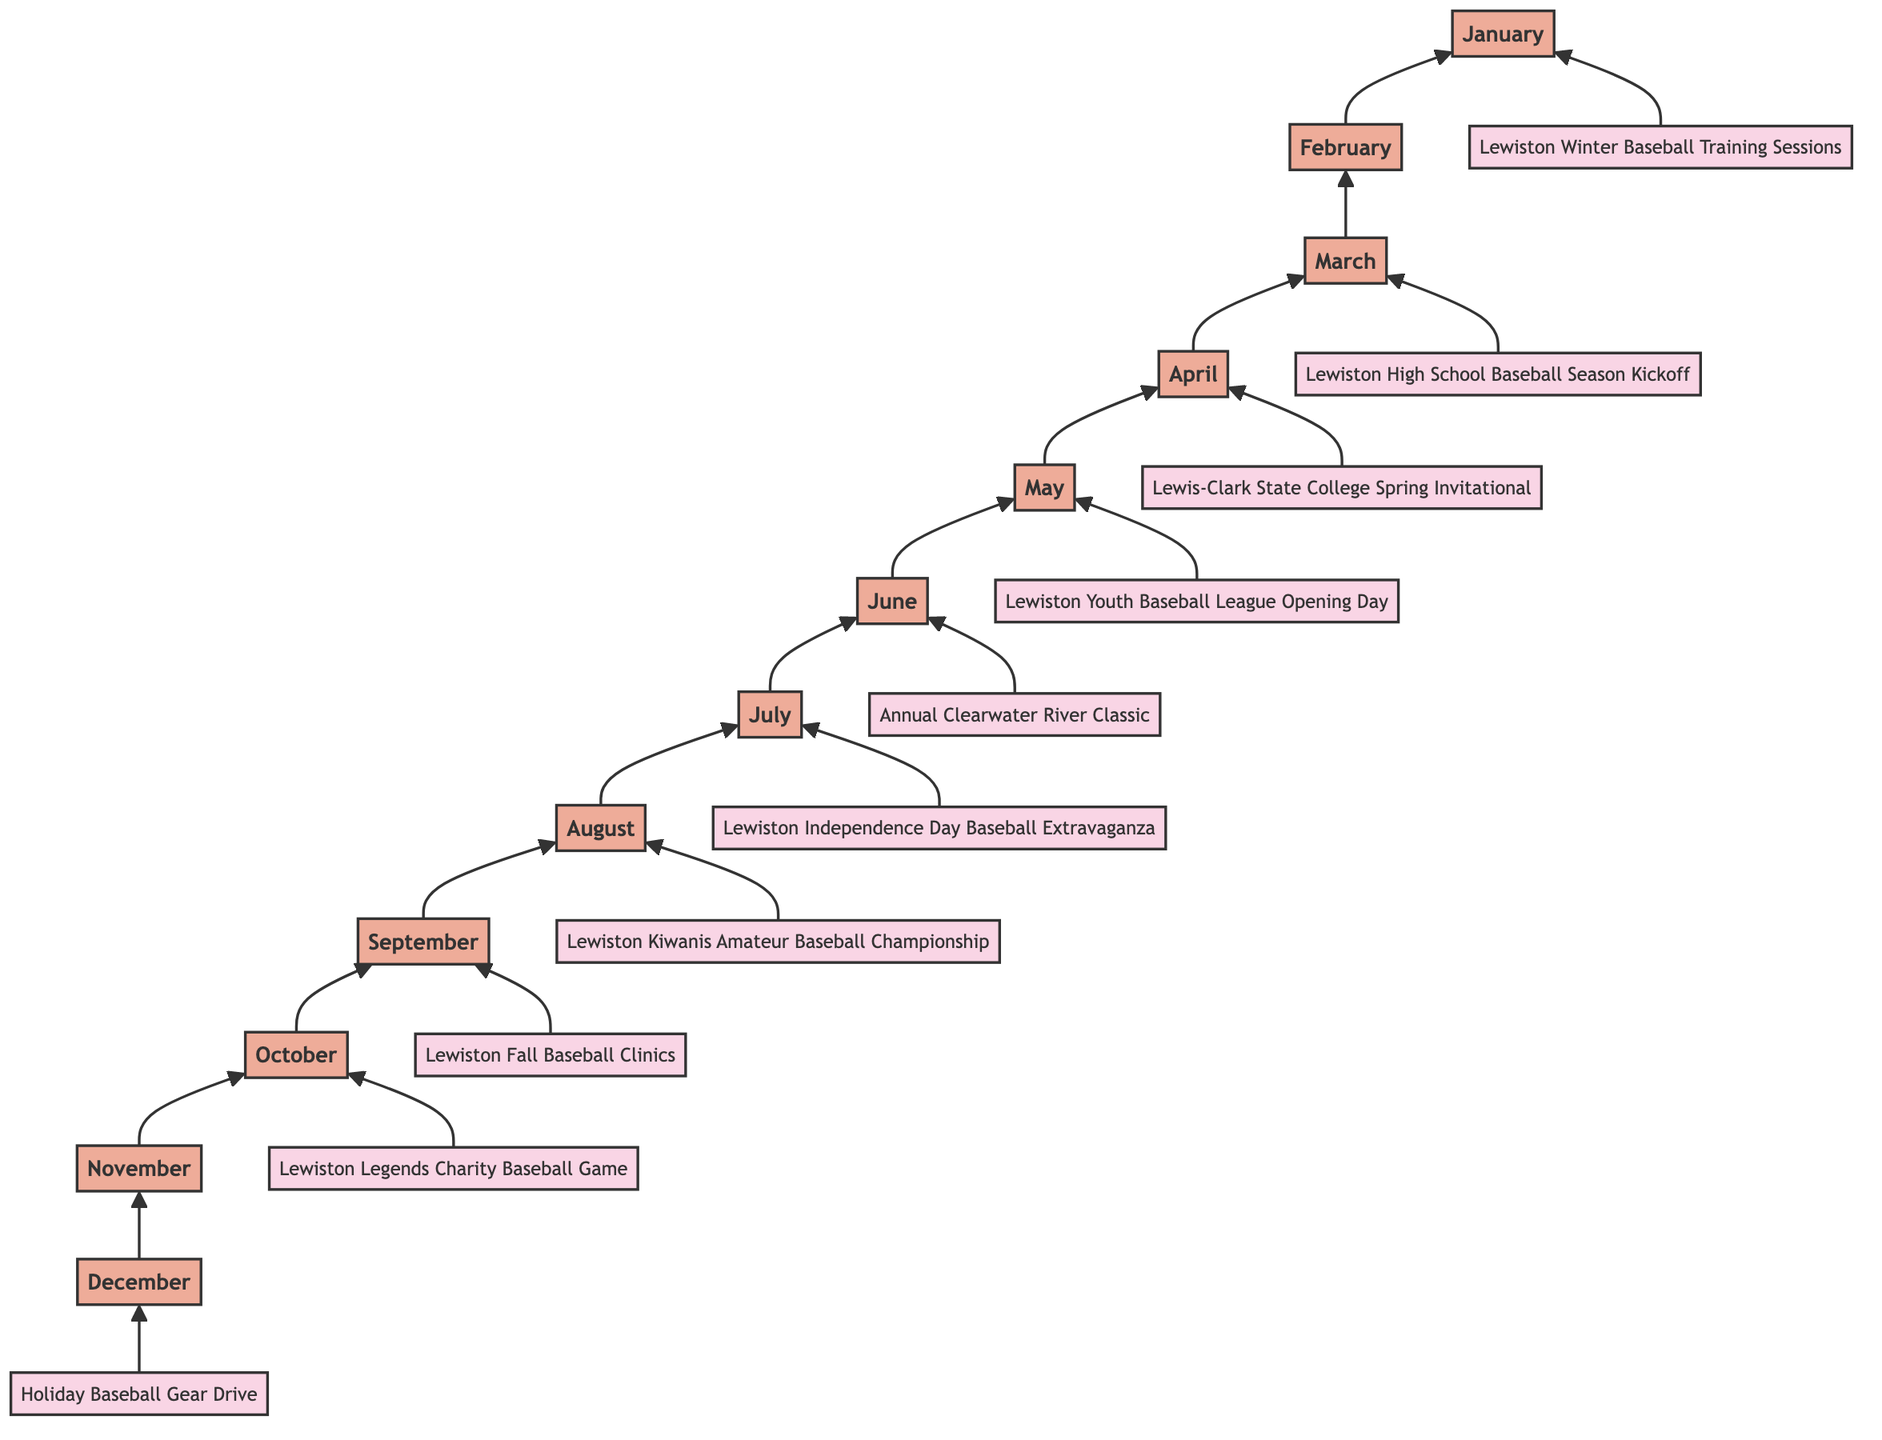What is the first event listed in the diagram? The first event is located at the bottom of the flow chart, which starts with the month of January. The event corresponding to January is "Lewiston Winter Baseball Training Sessions."
Answer: Lewiston Winter Baseball Training Sessions How many months are represented in the diagram? The diagram has a month node for each calendar month from December to January, making a total of 12 months included.
Answer: 12 Which month features the "Lewiston Youth Baseball League Opening Day"? By following the flow from the bottom to the top, I locate the event "Lewiston Youth Baseball League Opening Day," which is associated with the month of May.
Answer: May What event occurs right before the "Lewiston Legends Charity Baseball Game"? The event directly preceding the "Lewiston Legends Charity Baseball Game" is indicated in the diagram, which shows it occurs in October, while September holds the event "Lewiston Fall Baseball Clinics."
Answer: Lewiston Fall Baseball Clinics In which month do the Annual Clearwater River Classic take place? The diagram shows that this annual tournament is associated with the month of June, as this event points to June as outlined in the event nodes.
Answer: June Which event is scheduled for August? The diagram identifies the event scheduled for August as "Lewiston Kiwanis Amateur Baseball Championship."
Answer: Lewiston Kiwanis Amateur Baseball Championship How many events are listed in total in the diagram? Each event node corresponds to each month, and since there are 12 months, we conclude that there are also 12 events in total.
Answer: 12 Which month has the "Holiday Baseball Gear Drive"? The diagram indicates that the "Holiday Baseball Gear Drive" takes place in December.
Answer: December What is the last event to occur in the year according to the chart? The last node in the flow chart is December, and the associated event for December is "Holiday Baseball Gear Drive."
Answer: Holiday Baseball Gear Drive 